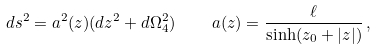<formula> <loc_0><loc_0><loc_500><loc_500>d s ^ { 2 } = a ^ { 2 } ( z ) ( d z ^ { 2 } + d \Omega ^ { 2 } _ { 4 } ) \quad a ( z ) = \frac { \ell } { \sinh ( z _ { 0 } + | z | ) } \, ,</formula> 